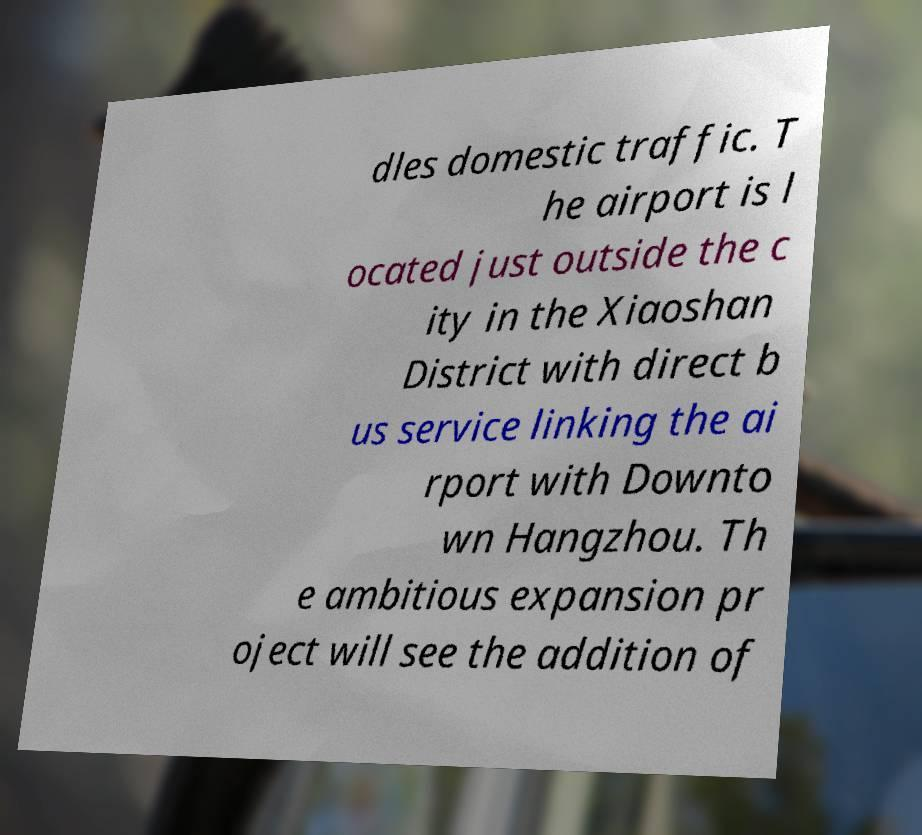What messages or text are displayed in this image? I need them in a readable, typed format. dles domestic traffic. T he airport is l ocated just outside the c ity in the Xiaoshan District with direct b us service linking the ai rport with Downto wn Hangzhou. Th e ambitious expansion pr oject will see the addition of 